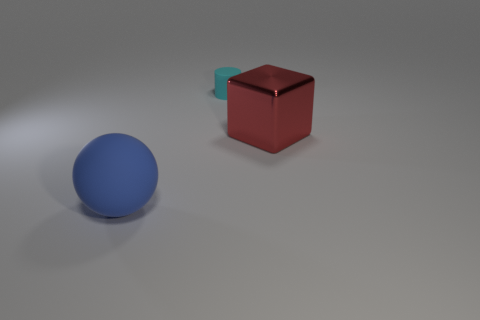Add 3 brown spheres. How many objects exist? 6 Subtract all cubes. How many objects are left? 2 Add 1 metallic cubes. How many metallic cubes exist? 2 Subtract 0 gray cylinders. How many objects are left? 3 Subtract all tiny blue rubber cubes. Subtract all balls. How many objects are left? 2 Add 2 cyan things. How many cyan things are left? 3 